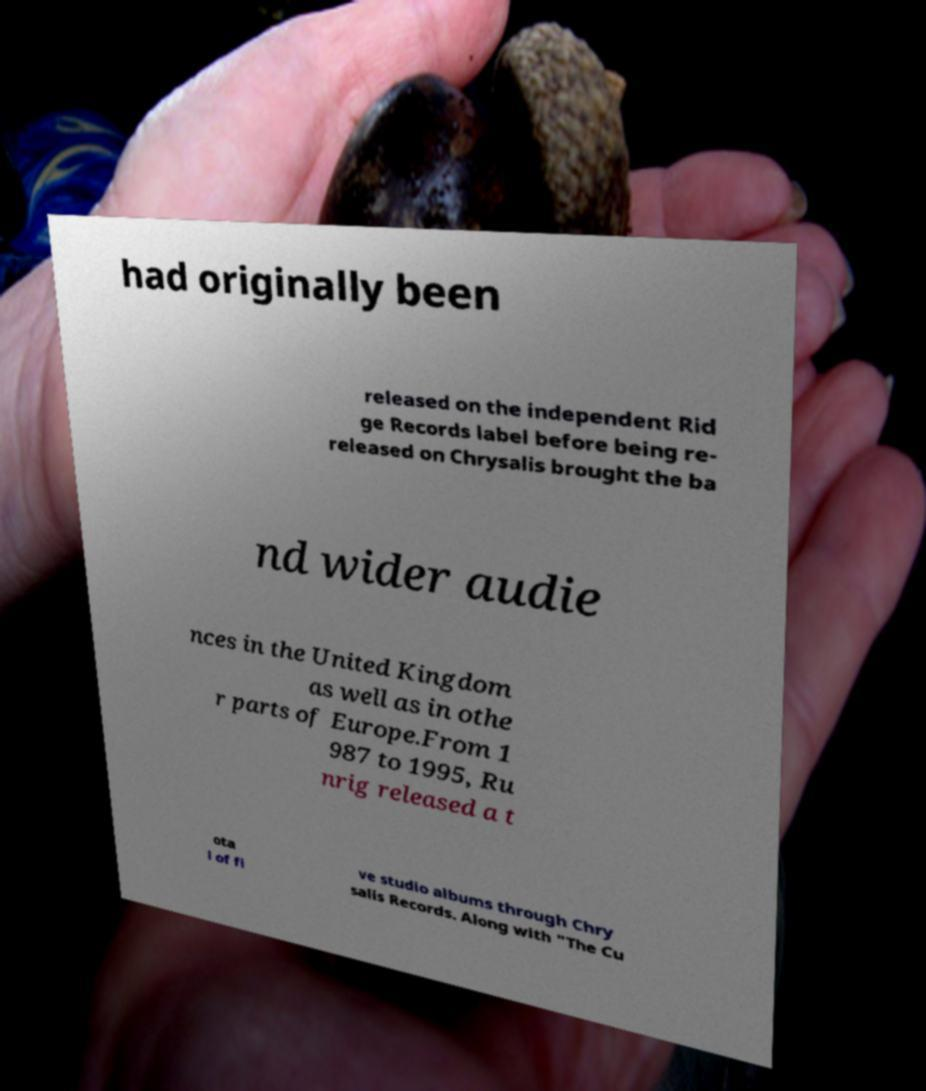For documentation purposes, I need the text within this image transcribed. Could you provide that? had originally been released on the independent Rid ge Records label before being re- released on Chrysalis brought the ba nd wider audie nces in the United Kingdom as well as in othe r parts of Europe.From 1 987 to 1995, Ru nrig released a t ota l of fi ve studio albums through Chry salis Records. Along with "The Cu 